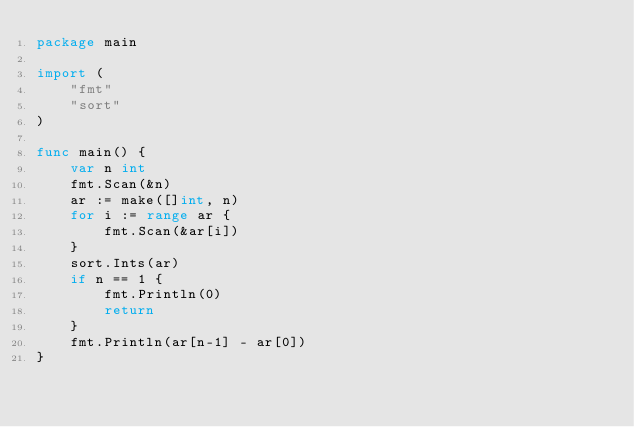<code> <loc_0><loc_0><loc_500><loc_500><_Go_>package main

import (
	"fmt"
	"sort"
)

func main() {
	var n int
	fmt.Scan(&n)
	ar := make([]int, n)
	for i := range ar {
		fmt.Scan(&ar[i])
	}
	sort.Ints(ar)
	if n == 1 {
		fmt.Println(0)
		return
	}
	fmt.Println(ar[n-1] - ar[0])
}
</code> 